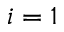Convert formula to latex. <formula><loc_0><loc_0><loc_500><loc_500>i = 1</formula> 